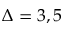Convert formula to latex. <formula><loc_0><loc_0><loc_500><loc_500>\Delta = 3 , 5</formula> 